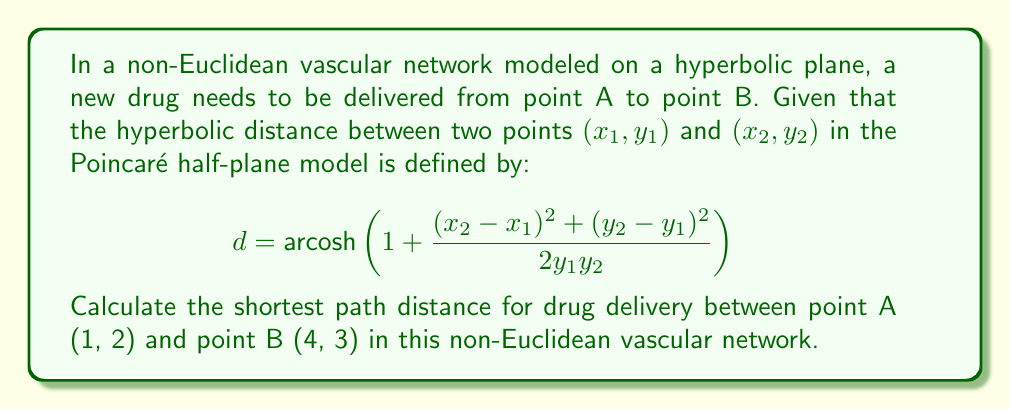Teach me how to tackle this problem. To solve this problem, we need to use the given hyperbolic distance formula and plug in the coordinates of points A and B. Let's break it down step by step:

1. Identify the coordinates:
   Point A: $(x_1, y_1) = (1, 2)$
   Point B: $(x_2, y_2) = (4, 3)$

2. Plug these values into the hyperbolic distance formula:

   $$d = \text{arcosh}\left(1 + \frac{(x_2 - x_1)^2 + (y_2 - y_1)^2}{2y_1y_2}\right)$$

3. Calculate the numerator $(x_2 - x_1)^2 + (y_2 - y_1)^2$:
   $(4 - 1)^2 + (3 - 2)^2 = 3^2 + 1^2 = 9 + 1 = 10$

4. Calculate the denominator $2y_1y_2$:
   $2 \cdot 2 \cdot 3 = 12$

5. Simplify the fraction inside the parentheses:
   $\frac{10}{12} = \frac{5}{6}$

6. Now our equation looks like this:

   $$d = \text{arcosh}\left(1 + \frac{5}{6}\right) = \text{arcosh}\left(\frac{11}{6}\right)$$

7. Calculate the final result:
   $$d = \text{arcosh}\left(\frac{11}{6}\right) \approx 1.0612$$

Therefore, the shortest path distance for drug delivery between points A and B in this non-Euclidean vascular network is approximately 1.0612 units.
Answer: $\text{arcosh}\left(\frac{11}{6}\right) \approx 1.0612$ units 